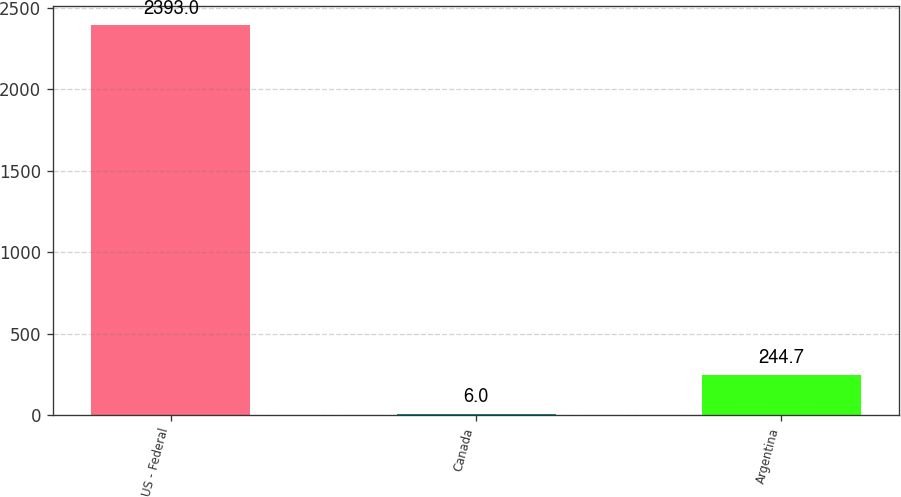Convert chart to OTSL. <chart><loc_0><loc_0><loc_500><loc_500><bar_chart><fcel>US - Federal<fcel>Canada<fcel>Argentina<nl><fcel>2393<fcel>6<fcel>244.7<nl></chart> 